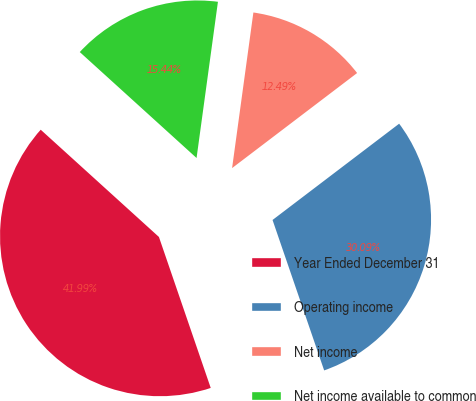<chart> <loc_0><loc_0><loc_500><loc_500><pie_chart><fcel>Year Ended December 31<fcel>Operating income<fcel>Net income<fcel>Net income available to common<nl><fcel>41.99%<fcel>30.09%<fcel>12.49%<fcel>15.44%<nl></chart> 